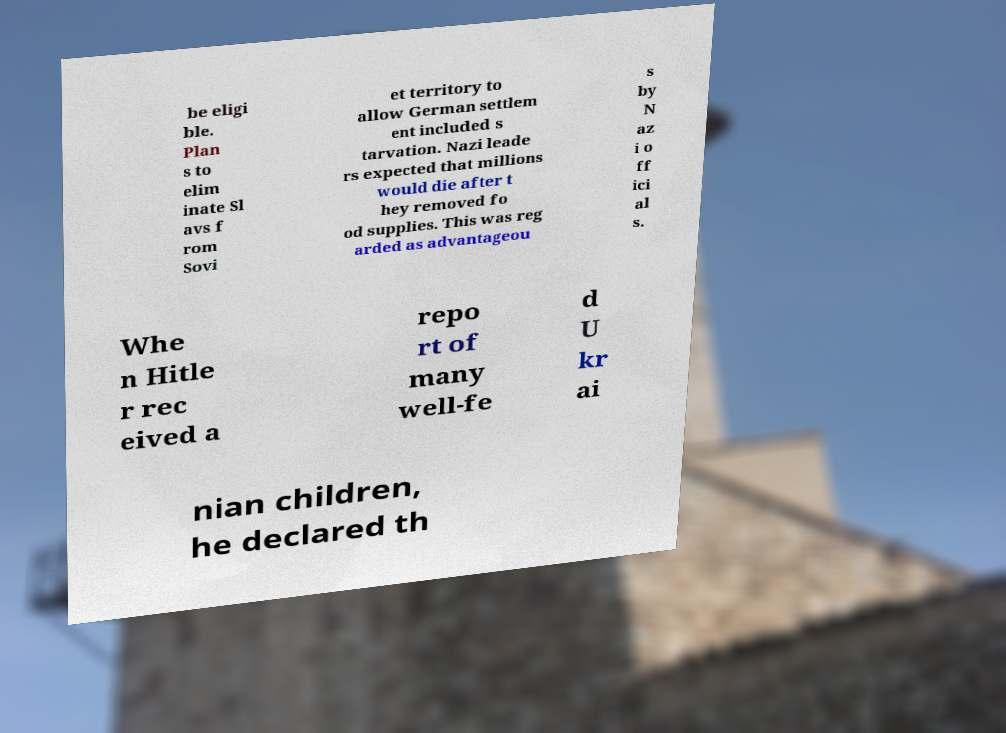I need the written content from this picture converted into text. Can you do that? be eligi ble. Plan s to elim inate Sl avs f rom Sovi et territory to allow German settlem ent included s tarvation. Nazi leade rs expected that millions would die after t hey removed fo od supplies. This was reg arded as advantageou s by N az i o ff ici al s. Whe n Hitle r rec eived a repo rt of many well-fe d U kr ai nian children, he declared th 